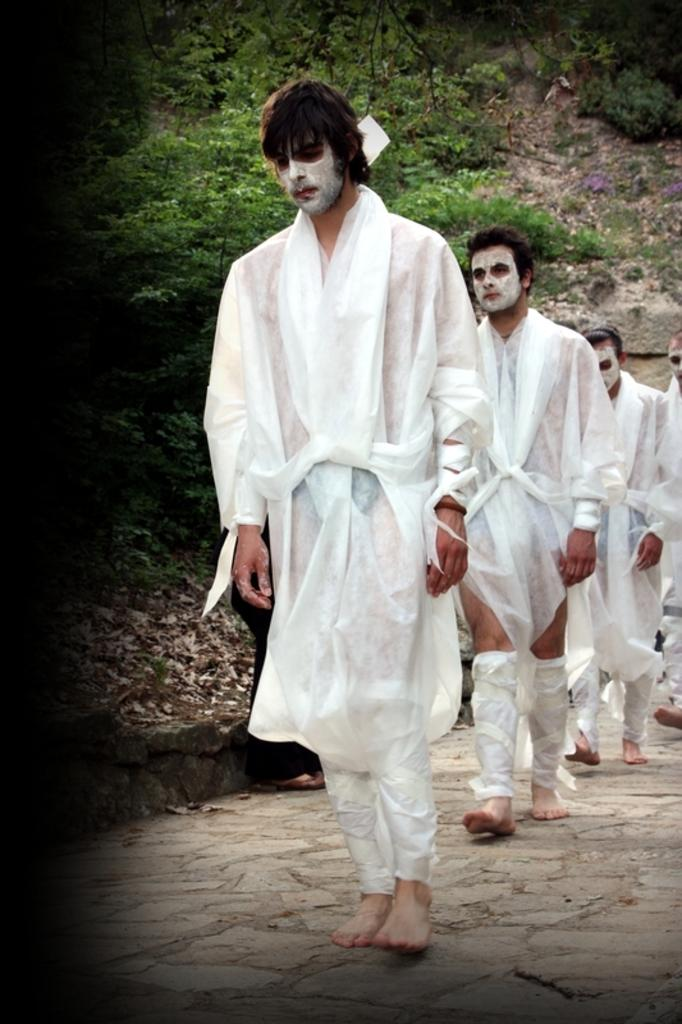What can be seen in the image? There are persons standing in the image. What are the persons wearing? The persons are wearing white dresses. What else is noticeable about the persons' appearance? The persons have white paint on their faces. What can be seen in the background of the image? There are trees in the background of the image. What statement does the tiger make in the image? There is no tiger present in the image, so it cannot make any statements. 